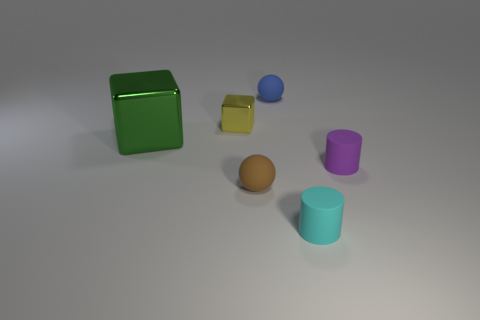What number of objects are either purple cylinders or small matte objects in front of the small metallic cube?
Offer a terse response. 3. How many other objects are the same size as the brown object?
Keep it short and to the point. 4. Is the material of the small sphere that is behind the green thing the same as the small cylinder that is on the right side of the tiny cyan rubber cylinder?
Provide a short and direct response. Yes. How many things are on the left side of the small brown ball?
Offer a very short reply. 2. How many yellow things are either shiny blocks or metal spheres?
Your answer should be very brief. 1. There is a blue thing that is the same size as the purple rubber cylinder; what material is it?
Keep it short and to the point. Rubber. There is a tiny object that is both on the right side of the blue rubber object and behind the cyan rubber cylinder; what is its shape?
Provide a short and direct response. Cylinder. What color is the metallic cube that is the same size as the cyan thing?
Offer a terse response. Yellow. There is a cylinder that is to the right of the cyan rubber object; is its size the same as the object that is left of the tiny yellow object?
Your answer should be compact. No. What size is the sphere in front of the block that is on the left side of the metallic thing to the right of the green shiny block?
Offer a terse response. Small. 